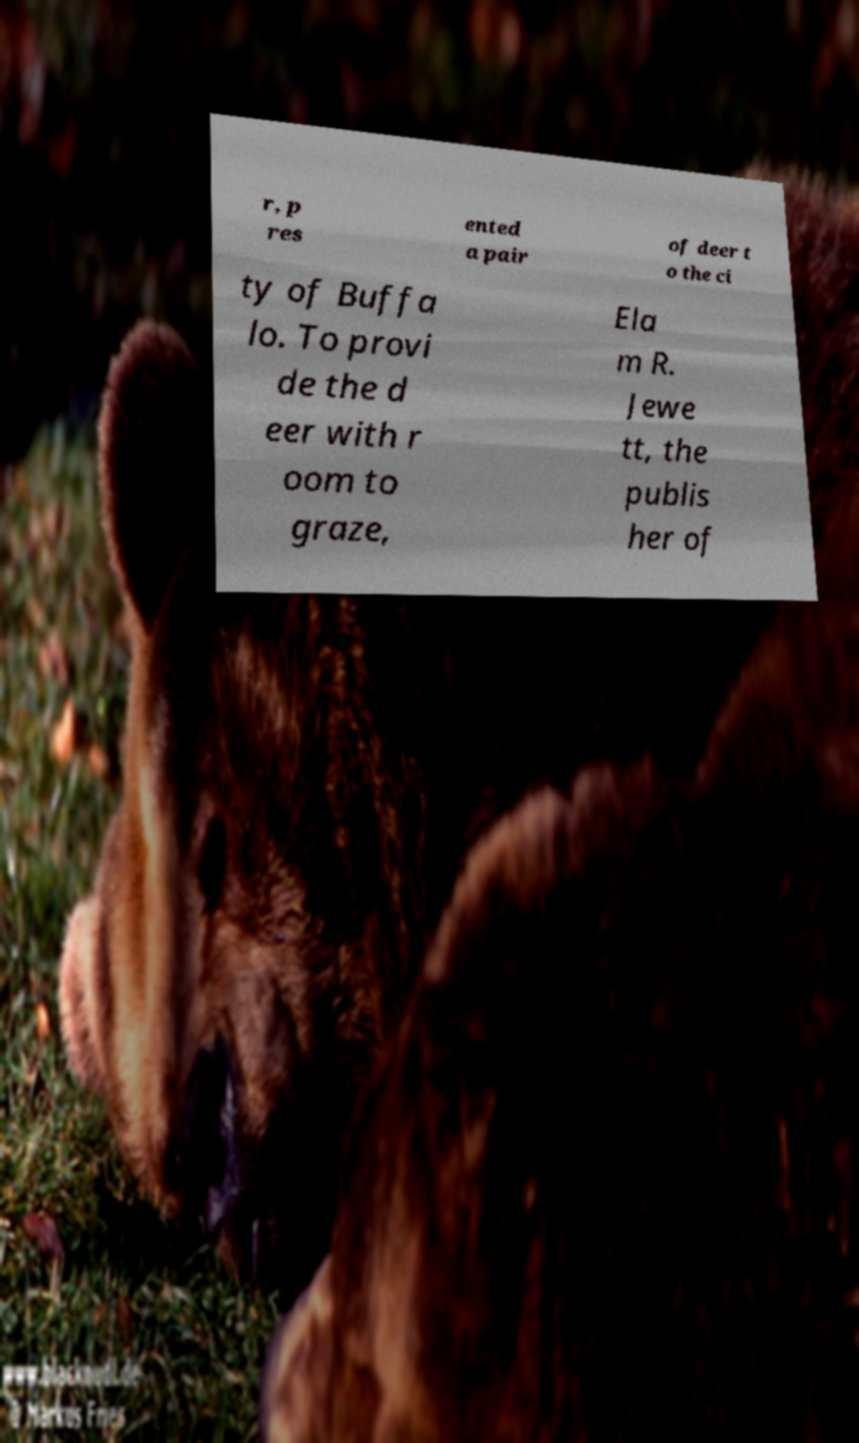Please identify and transcribe the text found in this image. r, p res ented a pair of deer t o the ci ty of Buffa lo. To provi de the d eer with r oom to graze, Ela m R. Jewe tt, the publis her of 